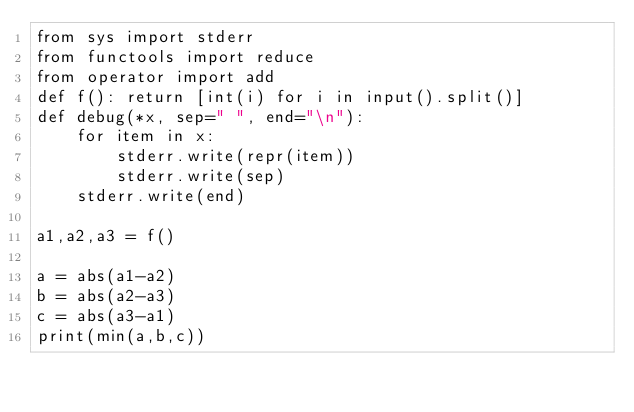<code> <loc_0><loc_0><loc_500><loc_500><_Python_>from sys import stderr
from functools import reduce
from operator import add
def f(): return [int(i) for i in input().split()]
def debug(*x, sep=" ", end="\n"):
    for item in x:
        stderr.write(repr(item))
        stderr.write(sep)
    stderr.write(end)

a1,a2,a3 = f()

a = abs(a1-a2)
b = abs(a2-a3)
c = abs(a3-a1)
print(min(a,b,c))</code> 